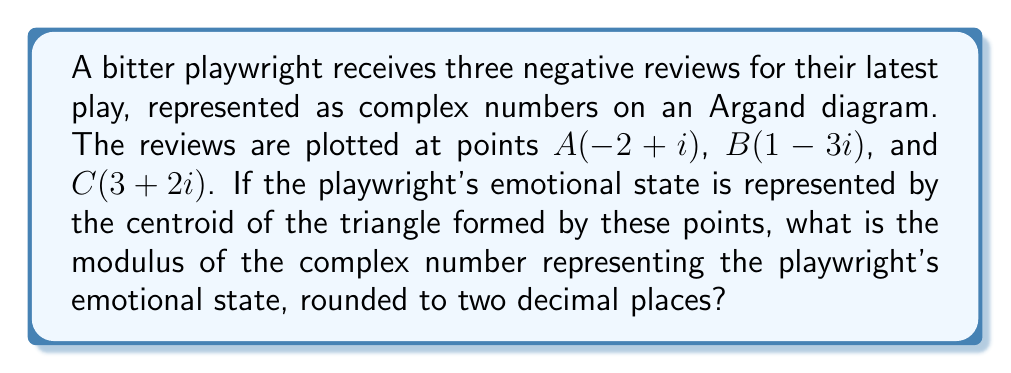What is the answer to this math problem? Let's approach this step-by-step:

1) The centroid of a triangle is the arithmetic mean of its vertices. In complex number form, we can calculate it as:

   $$z_{centroid} = \frac{z_A + z_B + z_C}{3}$$

2) Substituting the given points:

   $$z_{centroid} = \frac{(-2+i) + (1-3i) + (3+2i)}{3}$$

3) Simplifying the numerator:

   $$z_{centroid} = \frac{2 + 0i}{3} = \frac{2}{3}$$

4) The modulus of a complex number $a+bi$ is given by $\sqrt{a^2 + b^2}$. In this case, we have a real number, so the modulus is simply its absolute value:

   $$|z_{centroid}| = \left|\frac{2}{3}\right| = \frac{2}{3}$$

5) Converting to a decimal and rounding to two decimal places:

   $$\frac{2}{3} \approx 0.67$$

Thus, the modulus of the complex number representing the playwright's emotional state is 0.67.
Answer: 0.67 